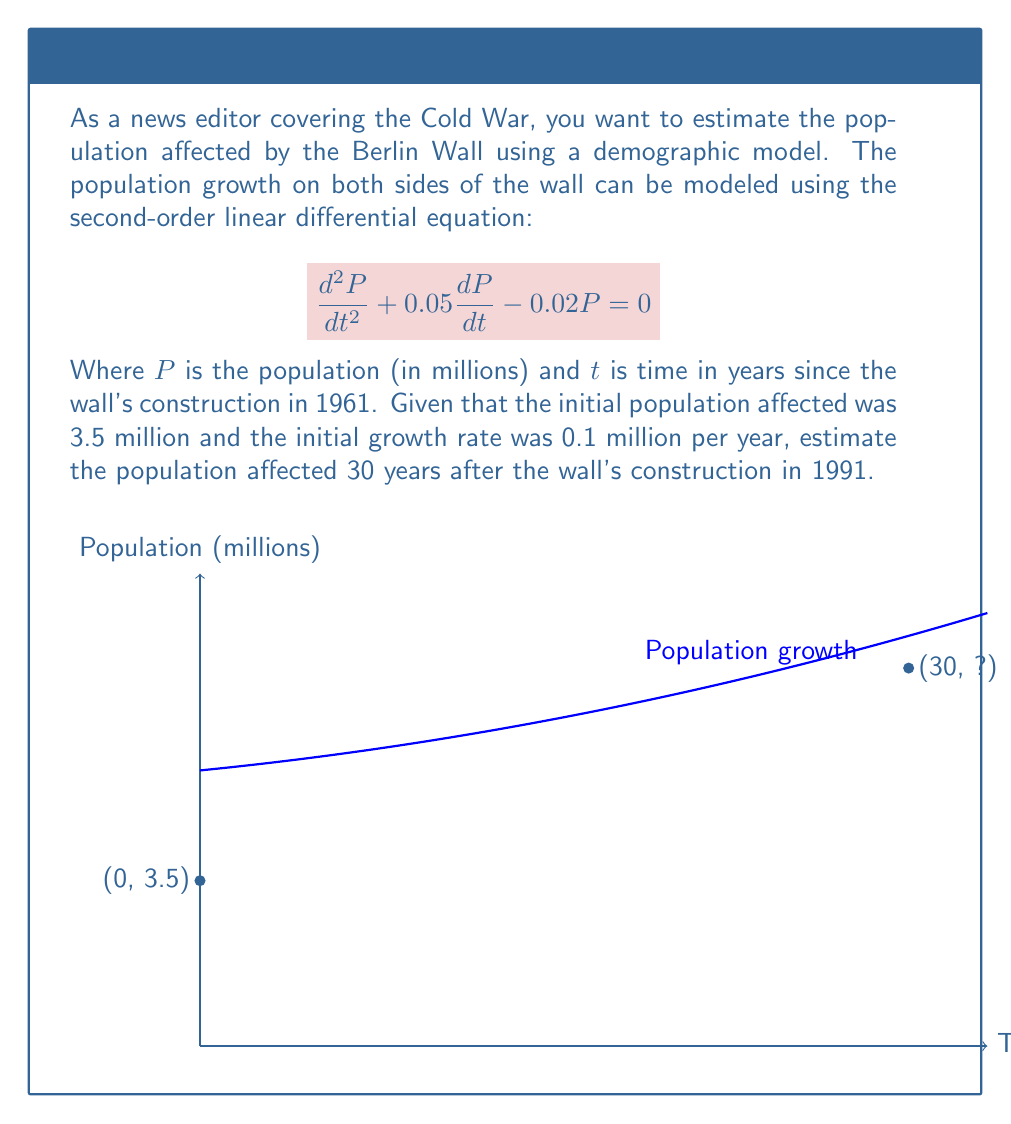Give your solution to this math problem. To solve this problem, we'll follow these steps:

1) The general solution for this second-order linear differential equation is:
   $$P(t) = c_1e^{r_1t} + c_2e^{r_2t}$$
   where $r_1$ and $r_2$ are roots of the characteristic equation:
   $$r^2 + 0.05r - 0.02 = 0$$

2) Solving the characteristic equation:
   $$r = \frac{-0.05 \pm \sqrt{0.05^2 + 4(0.02)}}{2} = \frac{-0.05 \pm \sqrt{0.0825}}{2}$$
   $$r_1 \approx 0.1194 \text{ and } r_2 \approx -0.1694$$

3) Our general solution is now:
   $$P(t) = c_1e^{0.1194t} + c_2e^{-0.1694t}$$

4) We use the initial conditions to find $c_1$ and $c_2$:
   At $t=0$, $P(0) = 3.5$ and $P'(0) = 0.1$

5) From $P(0) = 3.5$:
   $$3.5 = c_1 + c_2$$

6) From $P'(0) = 0.1$:
   $$0.1 = 0.1194c_1 - 0.1694c_2$$

7) Solving these equations:
   $$c_1 \approx 2.3358 \text{ and } c_2 \approx 1.1642$$

8) Our final solution is:
   $$P(t) = 2.3358e^{0.1194t} + 1.1642e^{-0.1694t}$$

9) To find the population after 30 years, we calculate $P(30)$:
   $$P(30) = 2.3358e^{0.1194(30)} + 1.1642e^{-0.1694(30)} \approx 8.9714$$

Therefore, the estimated population affected by the Berlin Wall in 1991 was approximately 8.97 million.
Answer: 8.97 million 